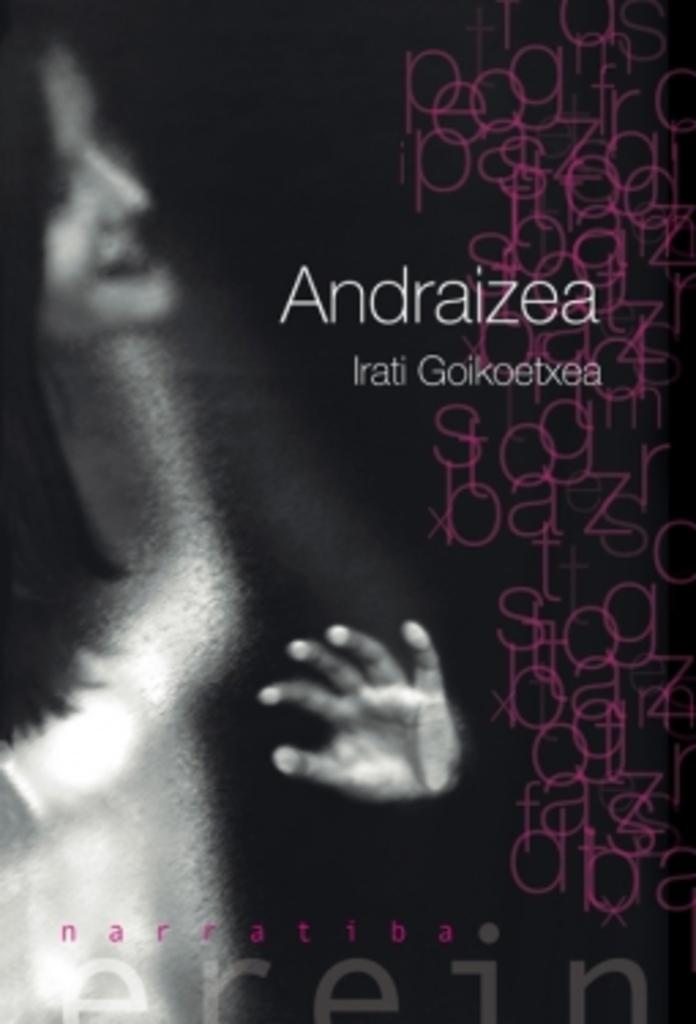<image>
Give a short and clear explanation of the subsequent image. A cover of a book with overlapping words by Irati 